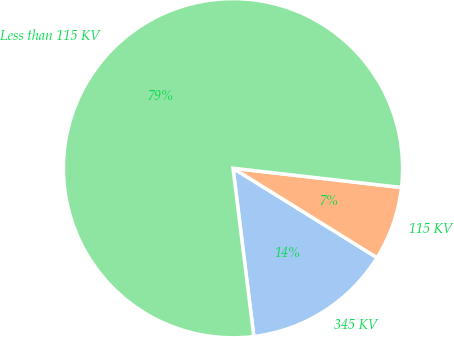Convert chart to OTSL. <chart><loc_0><loc_0><loc_500><loc_500><pie_chart><fcel>345 KV<fcel>115 KV<fcel>Less than 115 KV<nl><fcel>14.2%<fcel>7.03%<fcel>78.77%<nl></chart> 